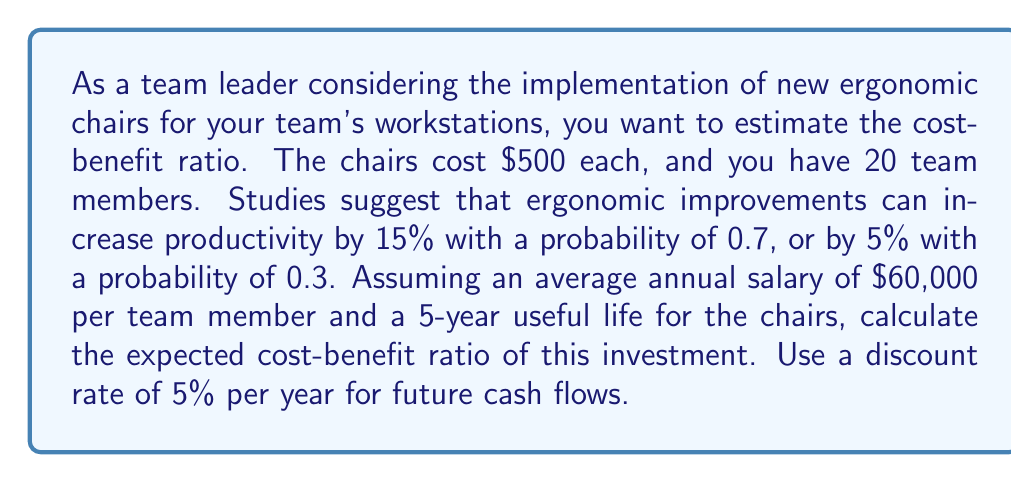Show me your answer to this math problem. Let's break this down step-by-step:

1) First, calculate the total cost of the chairs:
   $500 \times 20 = $10,000$

2) Now, let's calculate the expected annual productivity increase:
   $E(\text{productivity increase}) = 0.7 \times 15\% + 0.3 \times 5\% = 12\%$

3) The expected annual benefit per team member:
   $60,000 \times 12\% = $7,200$

4) Total annual benefit for the team:
   $7,200 \times 20 = $144,000$

5) We need to calculate the present value of these benefits over 5 years. The formula for the present value of an annuity is:

   $$PV = A \times \frac{1 - (1+r)^{-n}}{r}$$

   Where $A$ is the annual payment, $r$ is the discount rate, and $n$ is the number of years.

6) Plugging in our values:
   
   $$PV = 144,000 \times \frac{1 - (1.05)^{-5}}{0.05} = $623,774.71$$

7) The cost-benefit ratio is calculated as:

   $$\text{Cost-Benefit Ratio} = \frac{\text{Present Value of Benefits}}{\text{Cost}}$$

8) Plugging in our values:

   $$\text{Cost-Benefit Ratio} = \frac{623,774.71}{10,000} = 62.38$$
Answer: The expected cost-benefit ratio is 62.38, meaning for every dollar invested in the new chairs, the expected return is $62.38 over the 5-year period. 